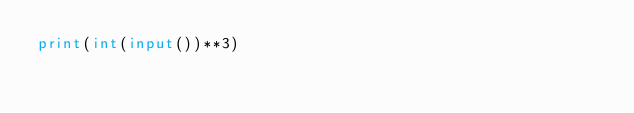Convert code to text. <code><loc_0><loc_0><loc_500><loc_500><_Python_>print(int(input())**3)</code> 